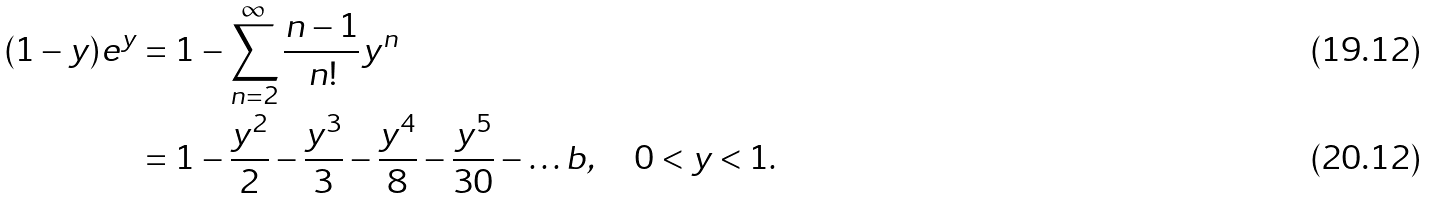Convert formula to latex. <formula><loc_0><loc_0><loc_500><loc_500>( 1 - y ) e ^ { y } & = 1 - \sum _ { n = 2 } ^ { \infty } \frac { n - 1 } { n ! } y ^ { n } \\ & = 1 - \frac { y ^ { 2 } } 2 - \frac { y ^ { 3 } } 3 - \frac { y ^ { 4 } } 8 - \frac { y ^ { 5 } } { 3 0 } - \dots b , \quad 0 < y < 1 .</formula> 